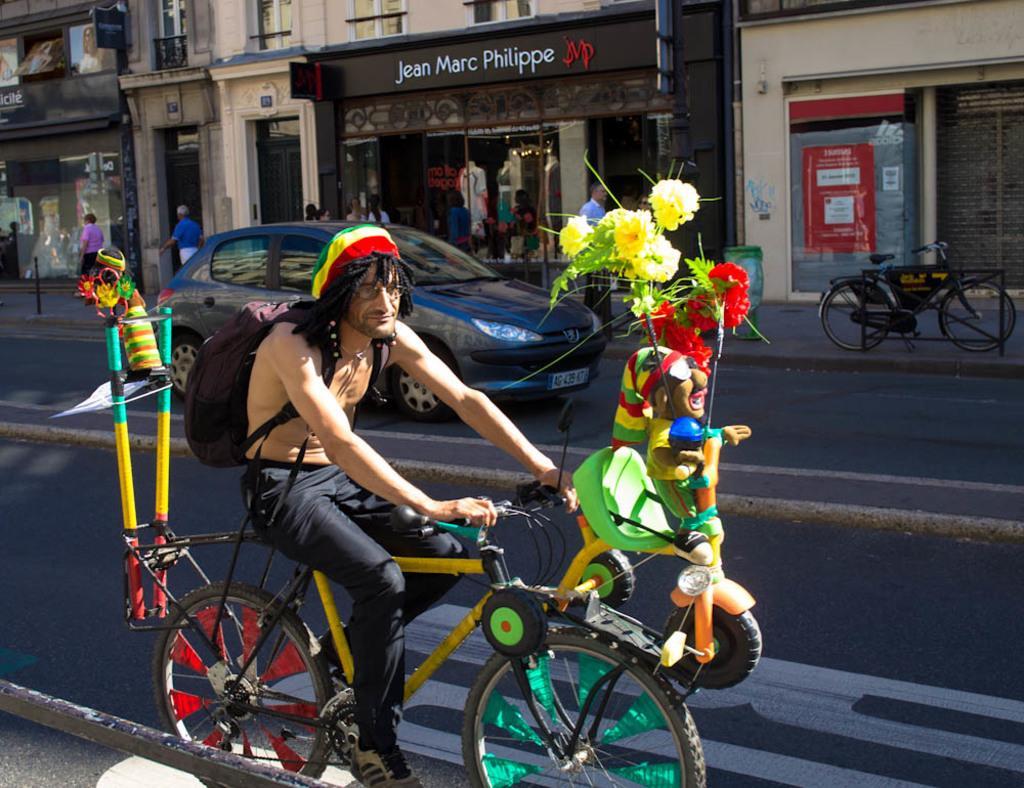Please provide a concise description of this image. Here in this picture we can see a person riding a bicycle on the road over there and we can see he is wearing cap and carrying a bag on him and we can see some toys and flowers on the bicycle present and beside him we can see a car and a bicycle also present over there and we can see buildings present all over there and we can see people standing and walking on the road over there. 